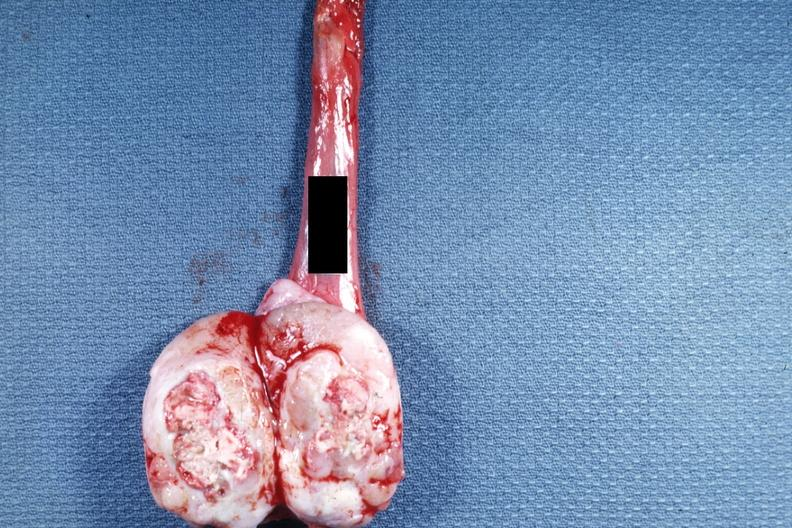s seminoma present?
Answer the question using a single word or phrase. Yes 